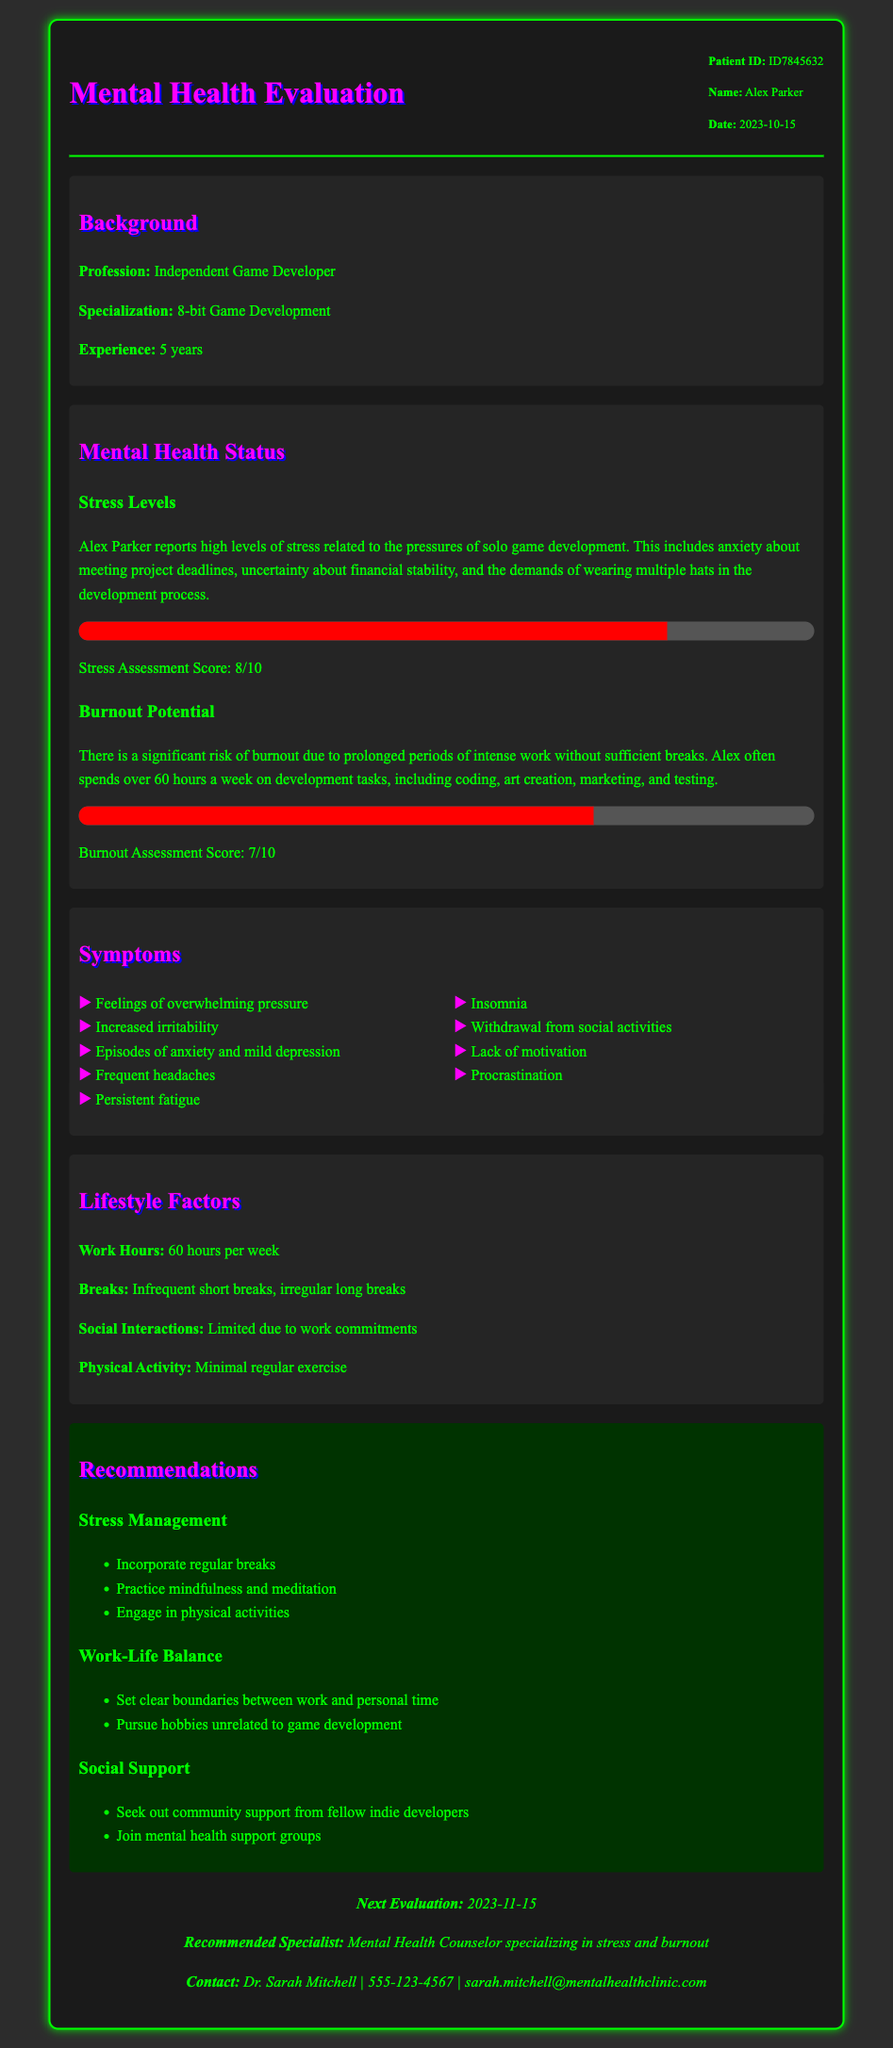What is the patient's name? The patient's name is specified at the beginning of the document in the patient info section.
Answer: Alex Parker What is the patient's profession? The patient's profession is clearly mentioned in the background section of the document.
Answer: Independent Game Developer What is the date of the evaluation? The evaluation date is provided in the patient info section of the document.
Answer: 2023-10-15 What is the stress assessment score? The stress assessment score is noted in the mental health status section of the document.
Answer: 8/10 What is the burnout assessment score? The burnout assessment score is detailed in the mental health status section of the document.
Answer: 7/10 How many hours per week does the patient work? The patient's work hours are mentioned in the lifestyle factors section of the document.
Answer: 60 hours What symptoms indicate burnout in the patient? Symptoms are listed in the symptoms section, which indicates the patient's mental health status.
Answer: Feelings of overwhelming pressure What is one recommended stress management technique? The recommendations section provides strategies to manage stress.
Answer: Incorporate regular breaks What is the recommended next evaluation date? The next evaluation date is specified in the follow-up section of the document.
Answer: 2023-11-15 Who is the recommended specialist for follow-up? The recommended specialist is mentioned at the end of the document in the follow-up section.
Answer: Mental Health Counselor specializing in stress and burnout 